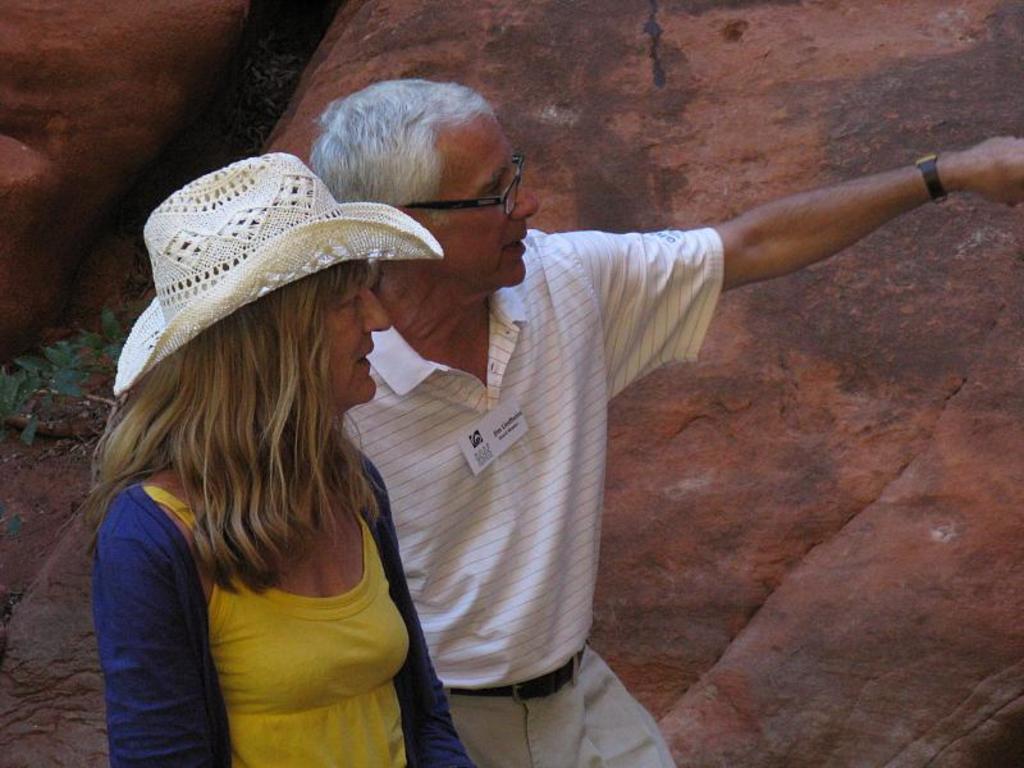Describe this image in one or two sentences. In this picture I can see two people on the left side. I can see the rock in the background. 